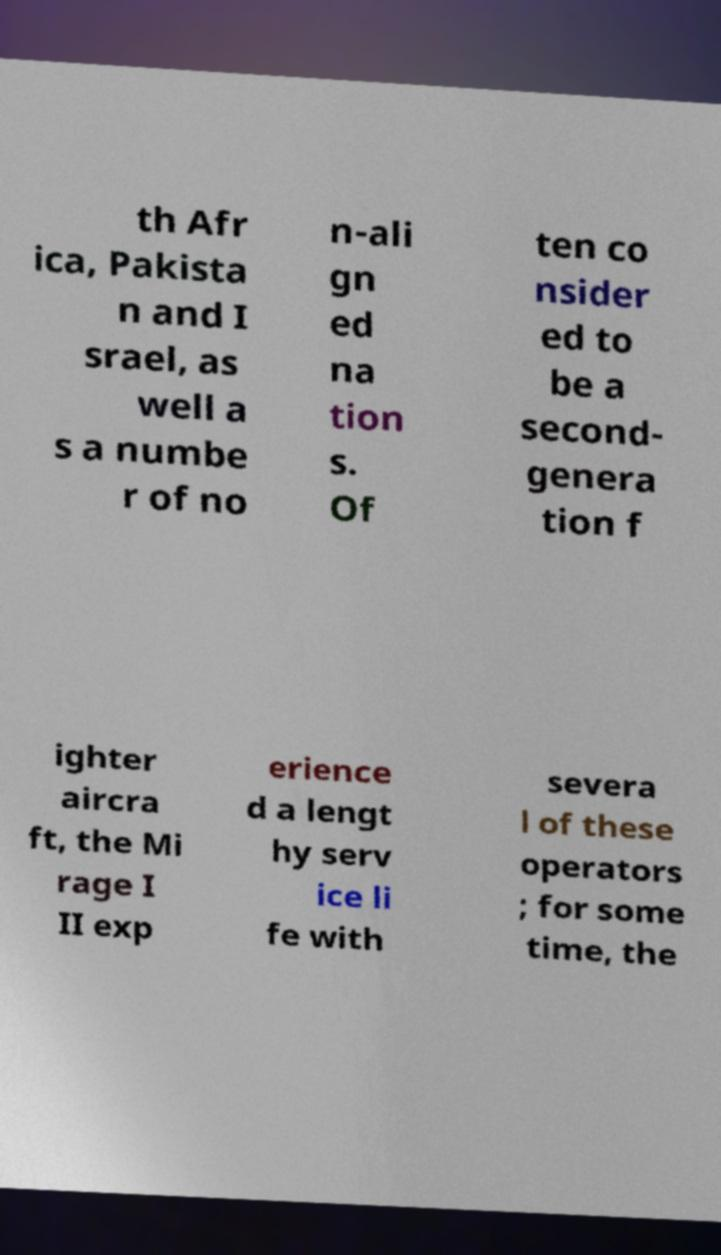Could you extract and type out the text from this image? th Afr ica, Pakista n and I srael, as well a s a numbe r of no n-ali gn ed na tion s. Of ten co nsider ed to be a second- genera tion f ighter aircra ft, the Mi rage I II exp erience d a lengt hy serv ice li fe with severa l of these operators ; for some time, the 